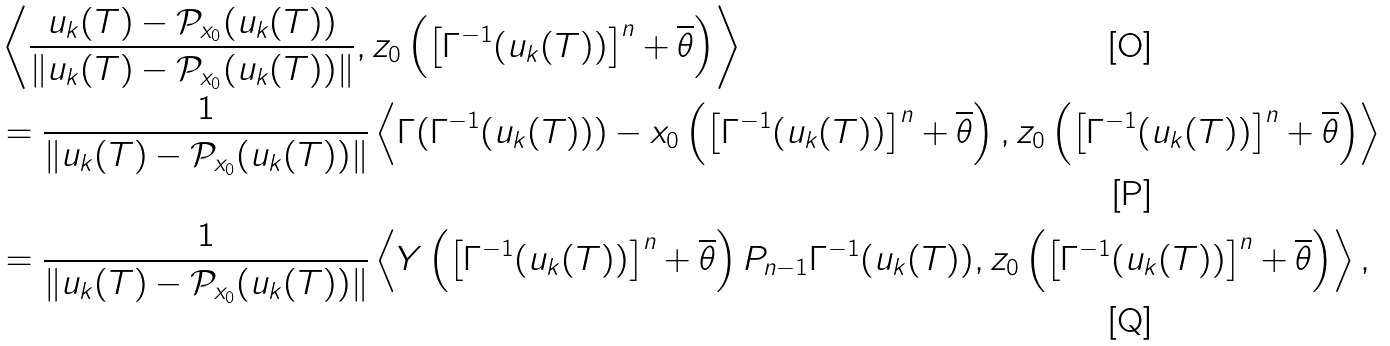<formula> <loc_0><loc_0><loc_500><loc_500>& \left < \frac { u _ { k } ( T ) - \mathcal { P } _ { x _ { 0 } } ( u _ { k } ( T ) ) } { \| u _ { k } ( T ) - \mathcal { P } _ { x _ { 0 } } ( u _ { k } ( T ) ) \| } , z _ { 0 } \left ( \left [ \Gamma ^ { - 1 } ( u _ { k } ( T ) ) \right ] ^ { n } + \overline { \theta } \right ) \right > \\ & = \frac { 1 } { \| u _ { k } ( T ) - \mathcal { P } _ { x _ { 0 } } ( u _ { k } ( T ) ) \| } \left < \Gamma ( \Gamma ^ { - 1 } ( u _ { k } ( T ) ) ) - x _ { 0 } \left ( \left [ \Gamma ^ { - 1 } ( u _ { k } ( T ) ) \right ] ^ { n } + \overline { \theta } \right ) , z _ { 0 } \left ( \left [ \Gamma ^ { - 1 } ( u _ { k } ( T ) ) \right ] ^ { n } + \overline { \theta } \right ) \right > \\ & = \frac { 1 } { \| u _ { k } ( T ) - \mathcal { P } _ { x _ { 0 } } ( u _ { k } ( T ) ) \| } \left < Y \left ( \left [ \Gamma ^ { - 1 } ( u _ { k } ( T ) ) \right ] ^ { n } + \overline { \theta } \right ) P _ { n - 1 } \Gamma ^ { - 1 } ( u _ { k } ( T ) ) , z _ { 0 } \left ( \left [ \Gamma ^ { - 1 } ( u _ { k } ( T ) ) \right ] ^ { n } + \overline { \theta } \right ) \right > ,</formula> 